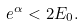Convert formula to latex. <formula><loc_0><loc_0><loc_500><loc_500>e ^ { \alpha } < 2 E _ { 0 } .</formula> 